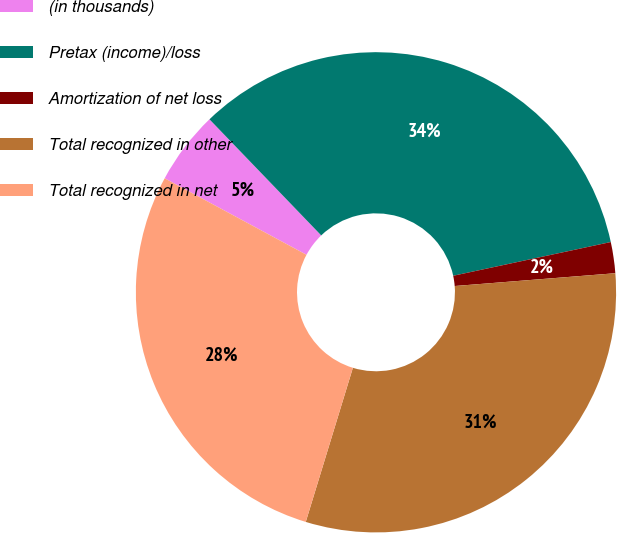<chart> <loc_0><loc_0><loc_500><loc_500><pie_chart><fcel>(in thousands)<fcel>Pretax (income)/loss<fcel>Amortization of net loss<fcel>Total recognized in other<fcel>Total recognized in net<nl><fcel>4.93%<fcel>33.84%<fcel>2.09%<fcel>30.99%<fcel>28.15%<nl></chart> 